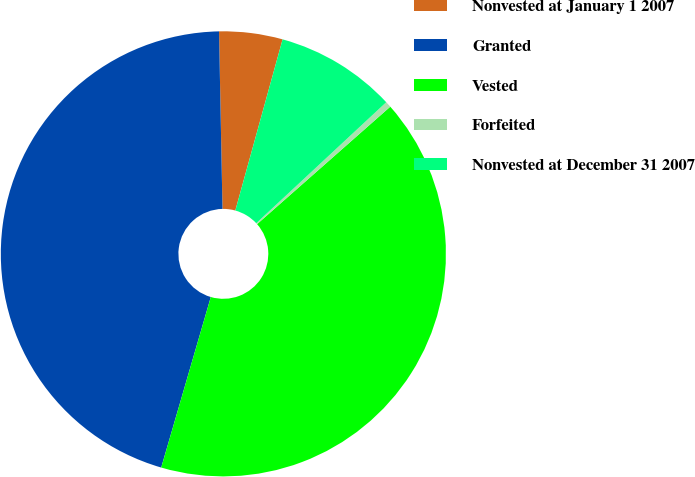Convert chart to OTSL. <chart><loc_0><loc_0><loc_500><loc_500><pie_chart><fcel>Nonvested at January 1 2007<fcel>Granted<fcel>Vested<fcel>Forfeited<fcel>Nonvested at December 31 2007<nl><fcel>4.6%<fcel>45.19%<fcel>41.01%<fcel>0.43%<fcel>8.78%<nl></chart> 